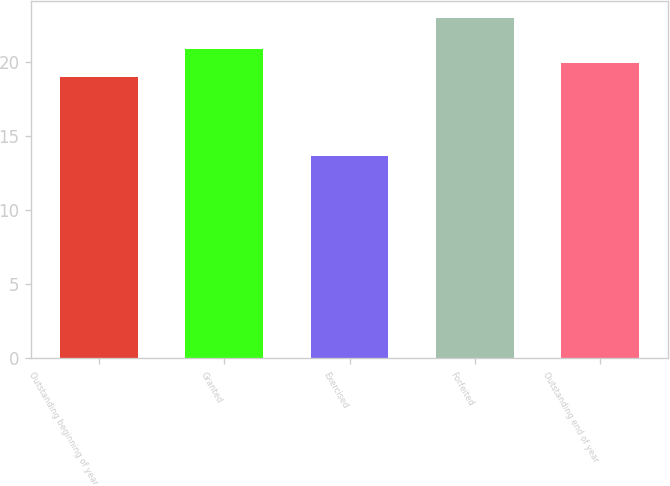<chart> <loc_0><loc_0><loc_500><loc_500><bar_chart><fcel>Outstanding beginning of year<fcel>Granted<fcel>Exercised<fcel>Forfeited<fcel>Outstanding end of year<nl><fcel>19<fcel>20.86<fcel>13.66<fcel>22.95<fcel>19.93<nl></chart> 